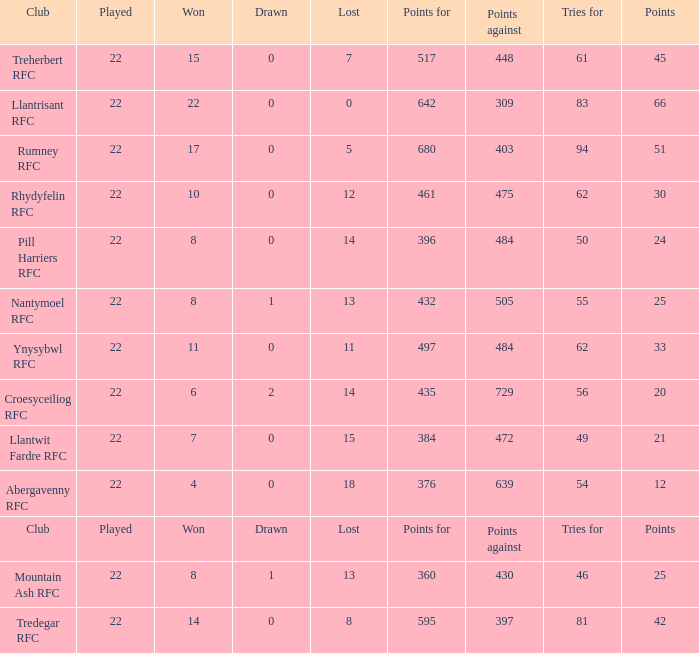For teams that won exactly 15, how many points were scored? 45.0. 